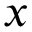<formula> <loc_0><loc_0><loc_500><loc_500>x</formula> 